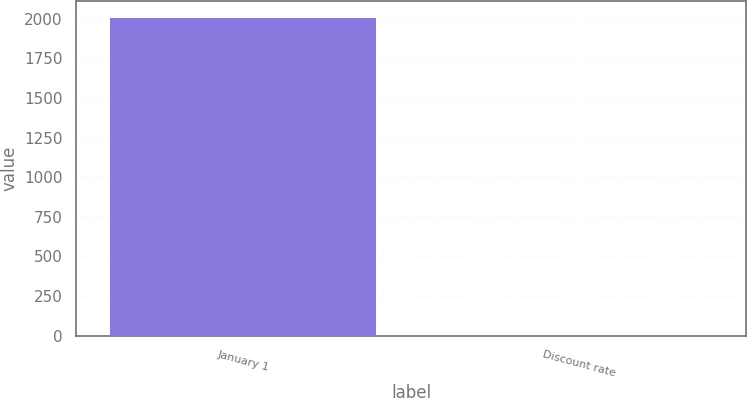<chart> <loc_0><loc_0><loc_500><loc_500><bar_chart><fcel>January 1<fcel>Discount rate<nl><fcel>2011<fcel>4.65<nl></chart> 